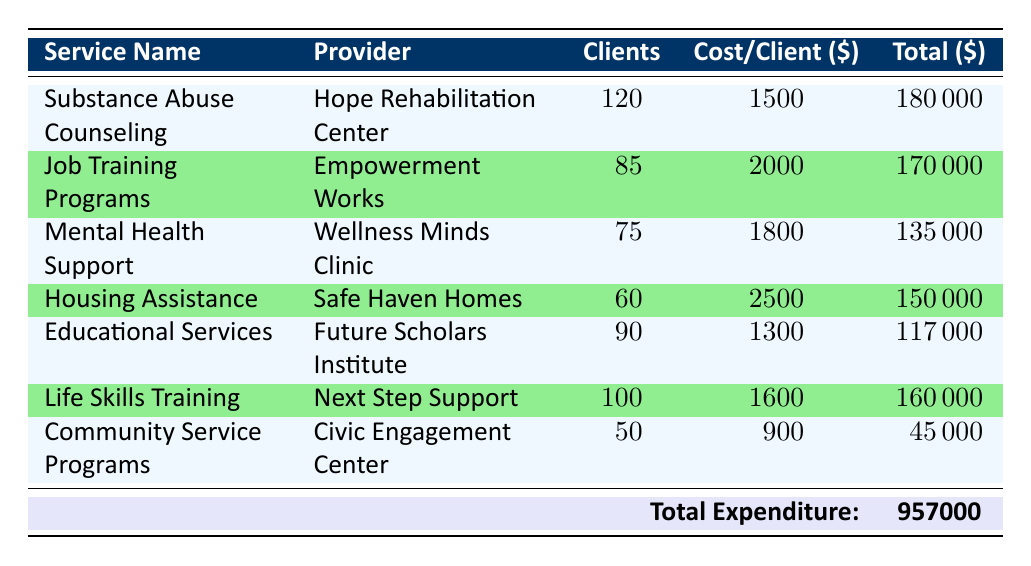What is the total expenditure on rehabilitation services for the fiscal year 2023? The total expenditure for all services is listed at the bottom of the table under "Total Expenditure." It shows an amount of 957000.
Answer: 957000 Which service has the highest cost per client? By examining the "Cost/Client" column for each service, the highest amount is found for "Housing Assistance," which costs 2500 per client.
Answer: Housing Assistance How many clients received Substance Abuse Counseling? The number of clients for Substance Abuse Counseling is provided directly in the "Clients" column, which shows a total of 120 clients.
Answer: 120 What is the total number of clients served across all services? To find the total number of clients, sum the values in the "Clients" column: 120 + 85 + 75 + 60 + 90 + 100 + 50 = 570.
Answer: 570 Did Community Service Programs have more clients than Mental Health Support? By comparing the "Clients" for both services, Community Service Programs had 50 clients while Mental Health Support had 75. 75 is greater than 50, thus the statement is false.
Answer: No What is the average cost per client across all services? To calculate the average cost per client, sum the total expenditures and divide by the total number of clients. The total expenditure is 957000, and the total number of clients is 570. Therefore, the average is 957000 / 570 = 1679. When rounded to the nearest whole number, the average cost per client is 1679.
Answer: 1679 Which service provided the lowest total expenditure and what is that amount? Examining the "Total" column, "Community Service Programs" provided the lowest expenditure, which is 45000.
Answer: 45000 What percentage of the total expenditure was spent on Job Training Programs? To find the percentage, use the formula: (Total expenditure for Job Training Programs / Total Expenditure) * 100. The expenditure for Job Training Programs is 170000, so: (170000 / 957000) * 100 = 17.77%.
Answer: 17.77% 